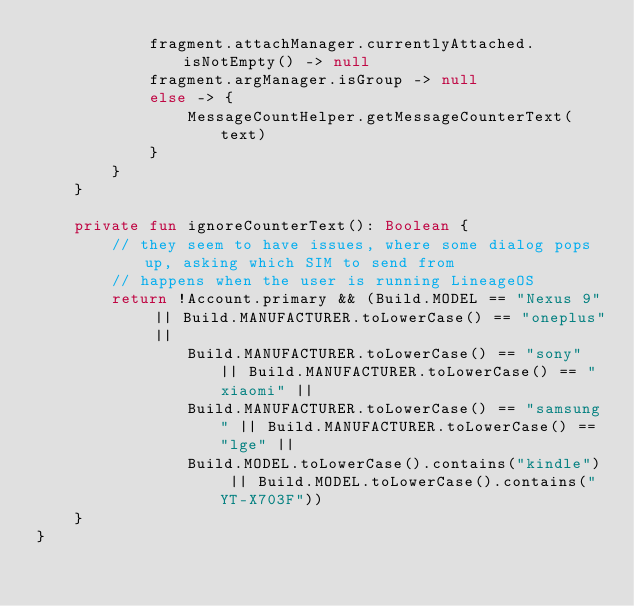<code> <loc_0><loc_0><loc_500><loc_500><_Kotlin_>            fragment.attachManager.currentlyAttached.isNotEmpty() -> null
            fragment.argManager.isGroup -> null
            else -> {
                MessageCountHelper.getMessageCounterText(text)
            }
        }
    }

    private fun ignoreCounterText(): Boolean {
        // they seem to have issues, where some dialog pops up, asking which SIM to send from
        // happens when the user is running LineageOS
        return !Account.primary && (Build.MODEL == "Nexus 9" || Build.MANUFACTURER.toLowerCase() == "oneplus" ||
                Build.MANUFACTURER.toLowerCase() == "sony" || Build.MANUFACTURER.toLowerCase() == "xiaomi" ||
                Build.MANUFACTURER.toLowerCase() == "samsung" || Build.MANUFACTURER.toLowerCase() == "lge" ||
                Build.MODEL.toLowerCase().contains("kindle") || Build.MODEL.toLowerCase().contains("YT-X703F"))
    }
}</code> 